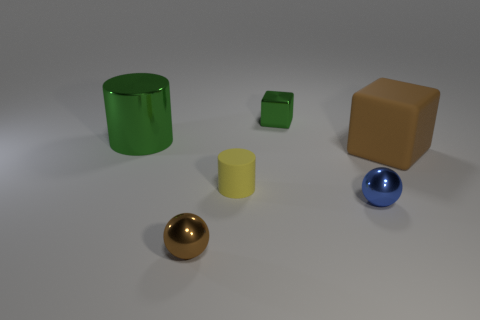There is a large shiny cylinder; is its color the same as the big thing to the right of the yellow matte cylinder?
Keep it short and to the point. No. There is a object that is in front of the large block and behind the blue ball; what shape is it?
Offer a very short reply. Cylinder. What number of gray shiny spheres are there?
Make the answer very short. 0. There is a object that is the same color as the large cube; what is its shape?
Provide a short and direct response. Sphere. The brown rubber thing that is the same shape as the small green metallic thing is what size?
Your response must be concise. Large. There is a big thing on the left side of the small brown metal thing; is it the same shape as the yellow thing?
Give a very brief answer. Yes. There is a sphere to the right of the metal block; what is its color?
Give a very brief answer. Blue. What number of other objects are there of the same size as the brown metallic thing?
Your response must be concise. 3. Are there any other things that are the same shape as the big rubber object?
Provide a succinct answer. Yes. Is the number of small cubes behind the green metallic cube the same as the number of yellow matte things?
Your answer should be very brief. No. 